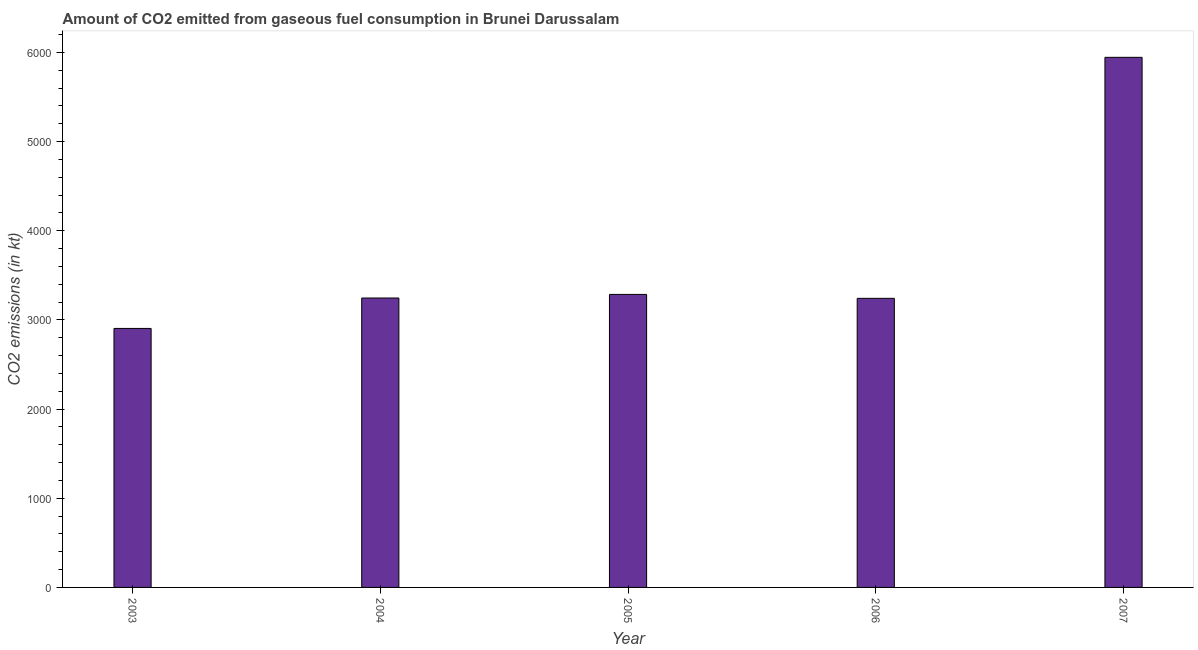Does the graph contain any zero values?
Your response must be concise. No. What is the title of the graph?
Make the answer very short. Amount of CO2 emitted from gaseous fuel consumption in Brunei Darussalam. What is the label or title of the Y-axis?
Your answer should be compact. CO2 emissions (in kt). What is the co2 emissions from gaseous fuel consumption in 2005?
Your response must be concise. 3285.63. Across all years, what is the maximum co2 emissions from gaseous fuel consumption?
Offer a terse response. 5944.21. Across all years, what is the minimum co2 emissions from gaseous fuel consumption?
Ensure brevity in your answer.  2904.26. In which year was the co2 emissions from gaseous fuel consumption maximum?
Your answer should be very brief. 2007. What is the sum of the co2 emissions from gaseous fuel consumption?
Provide a succinct answer. 1.86e+04. What is the difference between the co2 emissions from gaseous fuel consumption in 2003 and 2006?
Make the answer very short. -337.36. What is the average co2 emissions from gaseous fuel consumption per year?
Ensure brevity in your answer.  3724.2. What is the median co2 emissions from gaseous fuel consumption?
Your answer should be compact. 3245.3. What is the ratio of the co2 emissions from gaseous fuel consumption in 2003 to that in 2005?
Keep it short and to the point. 0.88. What is the difference between the highest and the second highest co2 emissions from gaseous fuel consumption?
Offer a very short reply. 2658.57. Is the sum of the co2 emissions from gaseous fuel consumption in 2003 and 2005 greater than the maximum co2 emissions from gaseous fuel consumption across all years?
Give a very brief answer. Yes. What is the difference between the highest and the lowest co2 emissions from gaseous fuel consumption?
Offer a very short reply. 3039.94. In how many years, is the co2 emissions from gaseous fuel consumption greater than the average co2 emissions from gaseous fuel consumption taken over all years?
Offer a very short reply. 1. What is the difference between two consecutive major ticks on the Y-axis?
Offer a very short reply. 1000. Are the values on the major ticks of Y-axis written in scientific E-notation?
Provide a short and direct response. No. What is the CO2 emissions (in kt) in 2003?
Give a very brief answer. 2904.26. What is the CO2 emissions (in kt) of 2004?
Keep it short and to the point. 3245.3. What is the CO2 emissions (in kt) in 2005?
Provide a succinct answer. 3285.63. What is the CO2 emissions (in kt) of 2006?
Provide a short and direct response. 3241.63. What is the CO2 emissions (in kt) of 2007?
Your answer should be very brief. 5944.21. What is the difference between the CO2 emissions (in kt) in 2003 and 2004?
Provide a short and direct response. -341.03. What is the difference between the CO2 emissions (in kt) in 2003 and 2005?
Your answer should be compact. -381.37. What is the difference between the CO2 emissions (in kt) in 2003 and 2006?
Keep it short and to the point. -337.36. What is the difference between the CO2 emissions (in kt) in 2003 and 2007?
Give a very brief answer. -3039.94. What is the difference between the CO2 emissions (in kt) in 2004 and 2005?
Your answer should be very brief. -40.34. What is the difference between the CO2 emissions (in kt) in 2004 and 2006?
Provide a succinct answer. 3.67. What is the difference between the CO2 emissions (in kt) in 2004 and 2007?
Your response must be concise. -2698.91. What is the difference between the CO2 emissions (in kt) in 2005 and 2006?
Provide a succinct answer. 44. What is the difference between the CO2 emissions (in kt) in 2005 and 2007?
Your answer should be compact. -2658.57. What is the difference between the CO2 emissions (in kt) in 2006 and 2007?
Give a very brief answer. -2702.58. What is the ratio of the CO2 emissions (in kt) in 2003 to that in 2004?
Your answer should be compact. 0.9. What is the ratio of the CO2 emissions (in kt) in 2003 to that in 2005?
Your answer should be compact. 0.88. What is the ratio of the CO2 emissions (in kt) in 2003 to that in 2006?
Offer a very short reply. 0.9. What is the ratio of the CO2 emissions (in kt) in 2003 to that in 2007?
Your response must be concise. 0.49. What is the ratio of the CO2 emissions (in kt) in 2004 to that in 2006?
Provide a succinct answer. 1. What is the ratio of the CO2 emissions (in kt) in 2004 to that in 2007?
Offer a terse response. 0.55. What is the ratio of the CO2 emissions (in kt) in 2005 to that in 2006?
Your answer should be compact. 1.01. What is the ratio of the CO2 emissions (in kt) in 2005 to that in 2007?
Offer a terse response. 0.55. What is the ratio of the CO2 emissions (in kt) in 2006 to that in 2007?
Your answer should be compact. 0.55. 